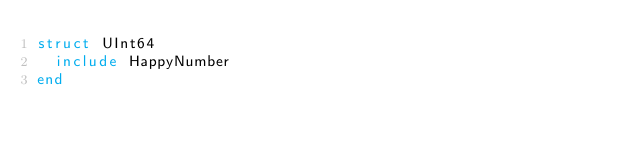<code> <loc_0><loc_0><loc_500><loc_500><_Crystal_>struct UInt64
  include HappyNumber
end
</code> 